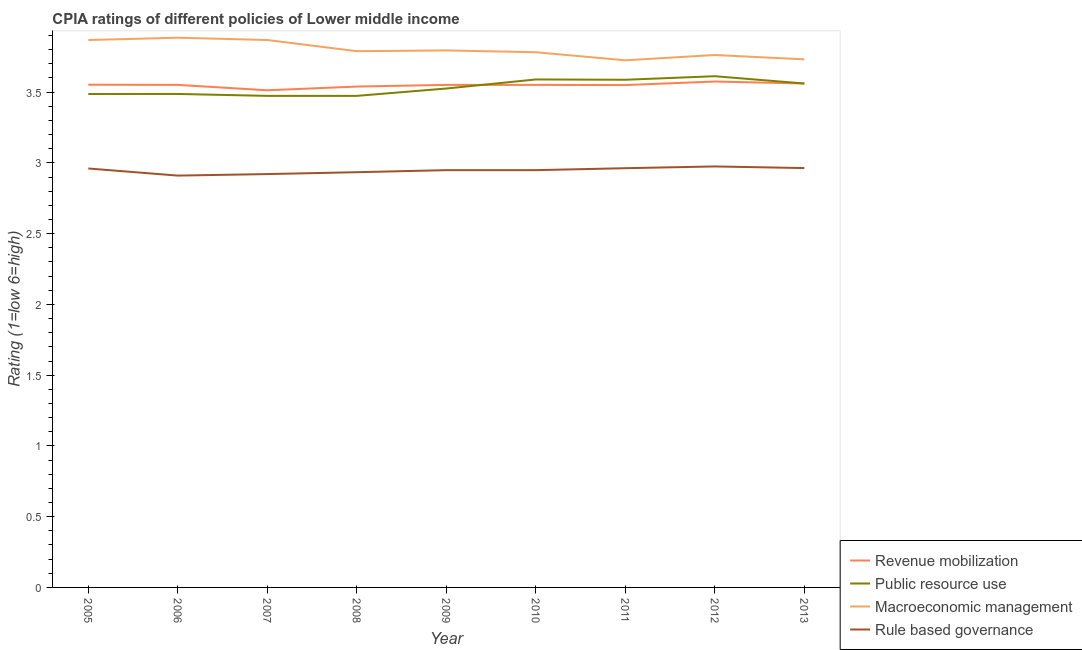Does the line corresponding to cpia rating of rule based governance intersect with the line corresponding to cpia rating of revenue mobilization?
Your answer should be compact. No. What is the cpia rating of public resource use in 2008?
Give a very brief answer. 3.47. Across all years, what is the maximum cpia rating of revenue mobilization?
Your answer should be compact. 3.58. Across all years, what is the minimum cpia rating of macroeconomic management?
Make the answer very short. 3.73. What is the total cpia rating of revenue mobilization in the graph?
Ensure brevity in your answer.  31.95. What is the difference between the cpia rating of public resource use in 2005 and that in 2008?
Give a very brief answer. 0.01. What is the difference between the cpia rating of macroeconomic management in 2012 and the cpia rating of rule based governance in 2007?
Make the answer very short. 0.84. What is the average cpia rating of revenue mobilization per year?
Offer a very short reply. 3.55. In the year 2008, what is the difference between the cpia rating of revenue mobilization and cpia rating of public resource use?
Your response must be concise. 0.07. What is the ratio of the cpia rating of rule based governance in 2009 to that in 2013?
Provide a short and direct response. 1. What is the difference between the highest and the second highest cpia rating of macroeconomic management?
Provide a succinct answer. 0.02. What is the difference between the highest and the lowest cpia rating of macroeconomic management?
Keep it short and to the point. 0.16. Is it the case that in every year, the sum of the cpia rating of macroeconomic management and cpia rating of revenue mobilization is greater than the sum of cpia rating of public resource use and cpia rating of rule based governance?
Provide a succinct answer. Yes. Is it the case that in every year, the sum of the cpia rating of revenue mobilization and cpia rating of public resource use is greater than the cpia rating of macroeconomic management?
Provide a succinct answer. Yes. Does the cpia rating of revenue mobilization monotonically increase over the years?
Keep it short and to the point. No. How many lines are there?
Your answer should be very brief. 4. What is the difference between two consecutive major ticks on the Y-axis?
Ensure brevity in your answer.  0.5. Does the graph contain any zero values?
Offer a very short reply. No. Does the graph contain grids?
Your answer should be compact. No. Where does the legend appear in the graph?
Provide a short and direct response. Bottom right. How are the legend labels stacked?
Your answer should be very brief. Vertical. What is the title of the graph?
Provide a short and direct response. CPIA ratings of different policies of Lower middle income. Does "CO2 damage" appear as one of the legend labels in the graph?
Offer a terse response. No. What is the label or title of the X-axis?
Offer a very short reply. Year. What is the label or title of the Y-axis?
Provide a succinct answer. Rating (1=low 6=high). What is the Rating (1=low 6=high) in Revenue mobilization in 2005?
Your response must be concise. 3.55. What is the Rating (1=low 6=high) of Public resource use in 2005?
Your response must be concise. 3.49. What is the Rating (1=low 6=high) in Macroeconomic management in 2005?
Provide a succinct answer. 3.87. What is the Rating (1=low 6=high) of Rule based governance in 2005?
Provide a short and direct response. 2.96. What is the Rating (1=low 6=high) in Revenue mobilization in 2006?
Provide a short and direct response. 3.55. What is the Rating (1=low 6=high) of Public resource use in 2006?
Provide a short and direct response. 3.49. What is the Rating (1=low 6=high) of Macroeconomic management in 2006?
Your answer should be compact. 3.88. What is the Rating (1=low 6=high) in Rule based governance in 2006?
Ensure brevity in your answer.  2.91. What is the Rating (1=low 6=high) of Revenue mobilization in 2007?
Provide a succinct answer. 3.51. What is the Rating (1=low 6=high) of Public resource use in 2007?
Offer a very short reply. 3.47. What is the Rating (1=low 6=high) of Macroeconomic management in 2007?
Your response must be concise. 3.87. What is the Rating (1=low 6=high) of Rule based governance in 2007?
Your response must be concise. 2.92. What is the Rating (1=low 6=high) of Revenue mobilization in 2008?
Ensure brevity in your answer.  3.54. What is the Rating (1=low 6=high) of Public resource use in 2008?
Ensure brevity in your answer.  3.47. What is the Rating (1=low 6=high) of Macroeconomic management in 2008?
Give a very brief answer. 3.79. What is the Rating (1=low 6=high) of Rule based governance in 2008?
Offer a very short reply. 2.93. What is the Rating (1=low 6=high) in Revenue mobilization in 2009?
Your answer should be compact. 3.55. What is the Rating (1=low 6=high) in Public resource use in 2009?
Make the answer very short. 3.53. What is the Rating (1=low 6=high) in Macroeconomic management in 2009?
Ensure brevity in your answer.  3.79. What is the Rating (1=low 6=high) of Rule based governance in 2009?
Offer a terse response. 2.95. What is the Rating (1=low 6=high) in Revenue mobilization in 2010?
Provide a succinct answer. 3.55. What is the Rating (1=low 6=high) of Public resource use in 2010?
Your answer should be compact. 3.59. What is the Rating (1=low 6=high) of Macroeconomic management in 2010?
Ensure brevity in your answer.  3.78. What is the Rating (1=low 6=high) in Rule based governance in 2010?
Your response must be concise. 2.95. What is the Rating (1=low 6=high) of Revenue mobilization in 2011?
Make the answer very short. 3.55. What is the Rating (1=low 6=high) of Public resource use in 2011?
Provide a short and direct response. 3.59. What is the Rating (1=low 6=high) in Macroeconomic management in 2011?
Provide a succinct answer. 3.73. What is the Rating (1=low 6=high) of Rule based governance in 2011?
Ensure brevity in your answer.  2.96. What is the Rating (1=low 6=high) of Revenue mobilization in 2012?
Ensure brevity in your answer.  3.58. What is the Rating (1=low 6=high) in Public resource use in 2012?
Offer a terse response. 3.61. What is the Rating (1=low 6=high) in Macroeconomic management in 2012?
Give a very brief answer. 3.76. What is the Rating (1=low 6=high) of Rule based governance in 2012?
Give a very brief answer. 2.98. What is the Rating (1=low 6=high) in Revenue mobilization in 2013?
Make the answer very short. 3.56. What is the Rating (1=low 6=high) in Public resource use in 2013?
Your answer should be very brief. 3.56. What is the Rating (1=low 6=high) of Macroeconomic management in 2013?
Your answer should be compact. 3.73. What is the Rating (1=low 6=high) in Rule based governance in 2013?
Your answer should be compact. 2.96. Across all years, what is the maximum Rating (1=low 6=high) in Revenue mobilization?
Offer a very short reply. 3.58. Across all years, what is the maximum Rating (1=low 6=high) of Public resource use?
Ensure brevity in your answer.  3.61. Across all years, what is the maximum Rating (1=low 6=high) in Macroeconomic management?
Ensure brevity in your answer.  3.88. Across all years, what is the maximum Rating (1=low 6=high) in Rule based governance?
Your answer should be very brief. 2.98. Across all years, what is the minimum Rating (1=low 6=high) of Revenue mobilization?
Keep it short and to the point. 3.51. Across all years, what is the minimum Rating (1=low 6=high) of Public resource use?
Give a very brief answer. 3.47. Across all years, what is the minimum Rating (1=low 6=high) of Macroeconomic management?
Ensure brevity in your answer.  3.73. Across all years, what is the minimum Rating (1=low 6=high) of Rule based governance?
Make the answer very short. 2.91. What is the total Rating (1=low 6=high) in Revenue mobilization in the graph?
Offer a terse response. 31.95. What is the total Rating (1=low 6=high) in Public resource use in the graph?
Your answer should be compact. 31.8. What is the total Rating (1=low 6=high) of Macroeconomic management in the graph?
Offer a terse response. 34.21. What is the total Rating (1=low 6=high) in Rule based governance in the graph?
Provide a short and direct response. 26.52. What is the difference between the Rating (1=low 6=high) in Revenue mobilization in 2005 and that in 2006?
Offer a terse response. 0. What is the difference between the Rating (1=low 6=high) in Public resource use in 2005 and that in 2006?
Keep it short and to the point. -0. What is the difference between the Rating (1=low 6=high) of Macroeconomic management in 2005 and that in 2006?
Provide a succinct answer. -0.02. What is the difference between the Rating (1=low 6=high) of Rule based governance in 2005 and that in 2006?
Give a very brief answer. 0.05. What is the difference between the Rating (1=low 6=high) in Revenue mobilization in 2005 and that in 2007?
Your response must be concise. 0.04. What is the difference between the Rating (1=low 6=high) of Public resource use in 2005 and that in 2007?
Your answer should be very brief. 0.01. What is the difference between the Rating (1=low 6=high) of Rule based governance in 2005 and that in 2007?
Your answer should be compact. 0.04. What is the difference between the Rating (1=low 6=high) of Revenue mobilization in 2005 and that in 2008?
Your answer should be very brief. 0.01. What is the difference between the Rating (1=low 6=high) in Public resource use in 2005 and that in 2008?
Ensure brevity in your answer.  0.01. What is the difference between the Rating (1=low 6=high) in Macroeconomic management in 2005 and that in 2008?
Provide a short and direct response. 0.08. What is the difference between the Rating (1=low 6=high) in Rule based governance in 2005 and that in 2008?
Provide a succinct answer. 0.03. What is the difference between the Rating (1=low 6=high) of Revenue mobilization in 2005 and that in 2009?
Keep it short and to the point. 0. What is the difference between the Rating (1=low 6=high) in Public resource use in 2005 and that in 2009?
Your answer should be compact. -0.04. What is the difference between the Rating (1=low 6=high) in Macroeconomic management in 2005 and that in 2009?
Ensure brevity in your answer.  0.07. What is the difference between the Rating (1=low 6=high) of Rule based governance in 2005 and that in 2009?
Provide a short and direct response. 0.01. What is the difference between the Rating (1=low 6=high) in Revenue mobilization in 2005 and that in 2010?
Your answer should be compact. 0. What is the difference between the Rating (1=low 6=high) in Public resource use in 2005 and that in 2010?
Provide a short and direct response. -0.1. What is the difference between the Rating (1=low 6=high) of Macroeconomic management in 2005 and that in 2010?
Ensure brevity in your answer.  0.09. What is the difference between the Rating (1=low 6=high) of Rule based governance in 2005 and that in 2010?
Provide a short and direct response. 0.01. What is the difference between the Rating (1=low 6=high) in Revenue mobilization in 2005 and that in 2011?
Make the answer very short. 0. What is the difference between the Rating (1=low 6=high) of Public resource use in 2005 and that in 2011?
Keep it short and to the point. -0.1. What is the difference between the Rating (1=low 6=high) in Macroeconomic management in 2005 and that in 2011?
Ensure brevity in your answer.  0.14. What is the difference between the Rating (1=low 6=high) in Rule based governance in 2005 and that in 2011?
Give a very brief answer. -0. What is the difference between the Rating (1=low 6=high) in Revenue mobilization in 2005 and that in 2012?
Your answer should be very brief. -0.02. What is the difference between the Rating (1=low 6=high) in Public resource use in 2005 and that in 2012?
Make the answer very short. -0.13. What is the difference between the Rating (1=low 6=high) in Macroeconomic management in 2005 and that in 2012?
Provide a succinct answer. 0.11. What is the difference between the Rating (1=low 6=high) of Rule based governance in 2005 and that in 2012?
Provide a short and direct response. -0.01. What is the difference between the Rating (1=low 6=high) of Revenue mobilization in 2005 and that in 2013?
Your response must be concise. -0.01. What is the difference between the Rating (1=low 6=high) in Public resource use in 2005 and that in 2013?
Provide a succinct answer. -0.07. What is the difference between the Rating (1=low 6=high) in Macroeconomic management in 2005 and that in 2013?
Your answer should be very brief. 0.14. What is the difference between the Rating (1=low 6=high) of Rule based governance in 2005 and that in 2013?
Your response must be concise. -0. What is the difference between the Rating (1=low 6=high) of Revenue mobilization in 2006 and that in 2007?
Your answer should be very brief. 0.04. What is the difference between the Rating (1=low 6=high) of Public resource use in 2006 and that in 2007?
Your answer should be compact. 0.01. What is the difference between the Rating (1=low 6=high) of Macroeconomic management in 2006 and that in 2007?
Keep it short and to the point. 0.02. What is the difference between the Rating (1=low 6=high) of Rule based governance in 2006 and that in 2007?
Offer a very short reply. -0.01. What is the difference between the Rating (1=low 6=high) in Revenue mobilization in 2006 and that in 2008?
Your response must be concise. 0.01. What is the difference between the Rating (1=low 6=high) of Public resource use in 2006 and that in 2008?
Your response must be concise. 0.01. What is the difference between the Rating (1=low 6=high) of Macroeconomic management in 2006 and that in 2008?
Give a very brief answer. 0.1. What is the difference between the Rating (1=low 6=high) of Rule based governance in 2006 and that in 2008?
Ensure brevity in your answer.  -0.02. What is the difference between the Rating (1=low 6=high) in Revenue mobilization in 2006 and that in 2009?
Make the answer very short. 0. What is the difference between the Rating (1=low 6=high) of Public resource use in 2006 and that in 2009?
Keep it short and to the point. -0.04. What is the difference between the Rating (1=low 6=high) in Macroeconomic management in 2006 and that in 2009?
Offer a very short reply. 0.09. What is the difference between the Rating (1=low 6=high) of Rule based governance in 2006 and that in 2009?
Offer a terse response. -0.04. What is the difference between the Rating (1=low 6=high) in Public resource use in 2006 and that in 2010?
Ensure brevity in your answer.  -0.1. What is the difference between the Rating (1=low 6=high) in Macroeconomic management in 2006 and that in 2010?
Provide a short and direct response. 0.1. What is the difference between the Rating (1=low 6=high) of Rule based governance in 2006 and that in 2010?
Give a very brief answer. -0.04. What is the difference between the Rating (1=low 6=high) of Revenue mobilization in 2006 and that in 2011?
Make the answer very short. 0. What is the difference between the Rating (1=low 6=high) of Public resource use in 2006 and that in 2011?
Offer a terse response. -0.1. What is the difference between the Rating (1=low 6=high) in Macroeconomic management in 2006 and that in 2011?
Offer a very short reply. 0.16. What is the difference between the Rating (1=low 6=high) of Rule based governance in 2006 and that in 2011?
Keep it short and to the point. -0.05. What is the difference between the Rating (1=low 6=high) of Revenue mobilization in 2006 and that in 2012?
Offer a terse response. -0.02. What is the difference between the Rating (1=low 6=high) in Public resource use in 2006 and that in 2012?
Give a very brief answer. -0.13. What is the difference between the Rating (1=low 6=high) in Macroeconomic management in 2006 and that in 2012?
Your answer should be very brief. 0.12. What is the difference between the Rating (1=low 6=high) of Rule based governance in 2006 and that in 2012?
Your answer should be compact. -0.06. What is the difference between the Rating (1=low 6=high) in Revenue mobilization in 2006 and that in 2013?
Make the answer very short. -0.01. What is the difference between the Rating (1=low 6=high) of Public resource use in 2006 and that in 2013?
Provide a short and direct response. -0.07. What is the difference between the Rating (1=low 6=high) of Macroeconomic management in 2006 and that in 2013?
Your answer should be compact. 0.15. What is the difference between the Rating (1=low 6=high) in Rule based governance in 2006 and that in 2013?
Give a very brief answer. -0.05. What is the difference between the Rating (1=low 6=high) in Revenue mobilization in 2007 and that in 2008?
Offer a very short reply. -0.03. What is the difference between the Rating (1=low 6=high) of Public resource use in 2007 and that in 2008?
Offer a very short reply. 0. What is the difference between the Rating (1=low 6=high) of Macroeconomic management in 2007 and that in 2008?
Give a very brief answer. 0.08. What is the difference between the Rating (1=low 6=high) of Rule based governance in 2007 and that in 2008?
Keep it short and to the point. -0.01. What is the difference between the Rating (1=low 6=high) in Revenue mobilization in 2007 and that in 2009?
Offer a very short reply. -0.04. What is the difference between the Rating (1=low 6=high) in Public resource use in 2007 and that in 2009?
Give a very brief answer. -0.05. What is the difference between the Rating (1=low 6=high) of Macroeconomic management in 2007 and that in 2009?
Provide a short and direct response. 0.07. What is the difference between the Rating (1=low 6=high) in Rule based governance in 2007 and that in 2009?
Your response must be concise. -0.03. What is the difference between the Rating (1=low 6=high) in Revenue mobilization in 2007 and that in 2010?
Your answer should be very brief. -0.04. What is the difference between the Rating (1=low 6=high) of Public resource use in 2007 and that in 2010?
Provide a succinct answer. -0.12. What is the difference between the Rating (1=low 6=high) of Macroeconomic management in 2007 and that in 2010?
Your answer should be compact. 0.09. What is the difference between the Rating (1=low 6=high) in Rule based governance in 2007 and that in 2010?
Your answer should be very brief. -0.03. What is the difference between the Rating (1=low 6=high) in Revenue mobilization in 2007 and that in 2011?
Offer a very short reply. -0.04. What is the difference between the Rating (1=low 6=high) in Public resource use in 2007 and that in 2011?
Your answer should be compact. -0.11. What is the difference between the Rating (1=low 6=high) of Macroeconomic management in 2007 and that in 2011?
Offer a very short reply. 0.14. What is the difference between the Rating (1=low 6=high) of Rule based governance in 2007 and that in 2011?
Give a very brief answer. -0.04. What is the difference between the Rating (1=low 6=high) in Revenue mobilization in 2007 and that in 2012?
Your answer should be very brief. -0.06. What is the difference between the Rating (1=low 6=high) in Public resource use in 2007 and that in 2012?
Provide a short and direct response. -0.14. What is the difference between the Rating (1=low 6=high) in Macroeconomic management in 2007 and that in 2012?
Provide a short and direct response. 0.11. What is the difference between the Rating (1=low 6=high) in Rule based governance in 2007 and that in 2012?
Your answer should be very brief. -0.05. What is the difference between the Rating (1=low 6=high) in Revenue mobilization in 2007 and that in 2013?
Your response must be concise. -0.05. What is the difference between the Rating (1=low 6=high) of Public resource use in 2007 and that in 2013?
Ensure brevity in your answer.  -0.09. What is the difference between the Rating (1=low 6=high) in Macroeconomic management in 2007 and that in 2013?
Provide a short and direct response. 0.14. What is the difference between the Rating (1=low 6=high) in Rule based governance in 2007 and that in 2013?
Ensure brevity in your answer.  -0.04. What is the difference between the Rating (1=low 6=high) in Revenue mobilization in 2008 and that in 2009?
Your answer should be compact. -0.01. What is the difference between the Rating (1=low 6=high) of Public resource use in 2008 and that in 2009?
Give a very brief answer. -0.05. What is the difference between the Rating (1=low 6=high) of Macroeconomic management in 2008 and that in 2009?
Provide a short and direct response. -0.01. What is the difference between the Rating (1=low 6=high) in Rule based governance in 2008 and that in 2009?
Keep it short and to the point. -0.01. What is the difference between the Rating (1=low 6=high) of Revenue mobilization in 2008 and that in 2010?
Your response must be concise. -0.01. What is the difference between the Rating (1=low 6=high) of Public resource use in 2008 and that in 2010?
Your answer should be very brief. -0.12. What is the difference between the Rating (1=low 6=high) in Macroeconomic management in 2008 and that in 2010?
Your answer should be compact. 0.01. What is the difference between the Rating (1=low 6=high) in Rule based governance in 2008 and that in 2010?
Offer a very short reply. -0.01. What is the difference between the Rating (1=low 6=high) in Revenue mobilization in 2008 and that in 2011?
Make the answer very short. -0.01. What is the difference between the Rating (1=low 6=high) of Public resource use in 2008 and that in 2011?
Offer a terse response. -0.11. What is the difference between the Rating (1=low 6=high) of Macroeconomic management in 2008 and that in 2011?
Offer a terse response. 0.06. What is the difference between the Rating (1=low 6=high) of Rule based governance in 2008 and that in 2011?
Provide a short and direct response. -0.03. What is the difference between the Rating (1=low 6=high) of Revenue mobilization in 2008 and that in 2012?
Your response must be concise. -0.04. What is the difference between the Rating (1=low 6=high) of Public resource use in 2008 and that in 2012?
Provide a succinct answer. -0.14. What is the difference between the Rating (1=low 6=high) of Macroeconomic management in 2008 and that in 2012?
Your answer should be very brief. 0.03. What is the difference between the Rating (1=low 6=high) of Rule based governance in 2008 and that in 2012?
Your answer should be very brief. -0.04. What is the difference between the Rating (1=low 6=high) of Revenue mobilization in 2008 and that in 2013?
Provide a succinct answer. -0.02. What is the difference between the Rating (1=low 6=high) of Public resource use in 2008 and that in 2013?
Make the answer very short. -0.09. What is the difference between the Rating (1=low 6=high) in Macroeconomic management in 2008 and that in 2013?
Ensure brevity in your answer.  0.06. What is the difference between the Rating (1=low 6=high) of Rule based governance in 2008 and that in 2013?
Ensure brevity in your answer.  -0.03. What is the difference between the Rating (1=low 6=high) of Revenue mobilization in 2009 and that in 2010?
Offer a terse response. 0. What is the difference between the Rating (1=low 6=high) of Public resource use in 2009 and that in 2010?
Your response must be concise. -0.06. What is the difference between the Rating (1=low 6=high) of Macroeconomic management in 2009 and that in 2010?
Your response must be concise. 0.01. What is the difference between the Rating (1=low 6=high) of Revenue mobilization in 2009 and that in 2011?
Provide a short and direct response. 0. What is the difference between the Rating (1=low 6=high) of Public resource use in 2009 and that in 2011?
Provide a succinct answer. -0.06. What is the difference between the Rating (1=low 6=high) of Macroeconomic management in 2009 and that in 2011?
Offer a very short reply. 0.07. What is the difference between the Rating (1=low 6=high) of Rule based governance in 2009 and that in 2011?
Provide a succinct answer. -0.01. What is the difference between the Rating (1=low 6=high) in Revenue mobilization in 2009 and that in 2012?
Your answer should be compact. -0.02. What is the difference between the Rating (1=low 6=high) of Public resource use in 2009 and that in 2012?
Give a very brief answer. -0.09. What is the difference between the Rating (1=low 6=high) of Macroeconomic management in 2009 and that in 2012?
Offer a very short reply. 0.03. What is the difference between the Rating (1=low 6=high) of Rule based governance in 2009 and that in 2012?
Your answer should be very brief. -0.03. What is the difference between the Rating (1=low 6=high) in Revenue mobilization in 2009 and that in 2013?
Offer a very short reply. -0.01. What is the difference between the Rating (1=low 6=high) of Public resource use in 2009 and that in 2013?
Your answer should be compact. -0.04. What is the difference between the Rating (1=low 6=high) in Macroeconomic management in 2009 and that in 2013?
Provide a succinct answer. 0.06. What is the difference between the Rating (1=low 6=high) of Rule based governance in 2009 and that in 2013?
Give a very brief answer. -0.01. What is the difference between the Rating (1=low 6=high) in Revenue mobilization in 2010 and that in 2011?
Your response must be concise. 0. What is the difference between the Rating (1=low 6=high) of Public resource use in 2010 and that in 2011?
Ensure brevity in your answer.  0. What is the difference between the Rating (1=low 6=high) in Macroeconomic management in 2010 and that in 2011?
Give a very brief answer. 0.06. What is the difference between the Rating (1=low 6=high) of Rule based governance in 2010 and that in 2011?
Offer a terse response. -0.01. What is the difference between the Rating (1=low 6=high) in Revenue mobilization in 2010 and that in 2012?
Offer a very short reply. -0.02. What is the difference between the Rating (1=low 6=high) in Public resource use in 2010 and that in 2012?
Your answer should be very brief. -0.02. What is the difference between the Rating (1=low 6=high) in Macroeconomic management in 2010 and that in 2012?
Your answer should be very brief. 0.02. What is the difference between the Rating (1=low 6=high) of Rule based governance in 2010 and that in 2012?
Keep it short and to the point. -0.03. What is the difference between the Rating (1=low 6=high) in Revenue mobilization in 2010 and that in 2013?
Make the answer very short. -0.01. What is the difference between the Rating (1=low 6=high) of Public resource use in 2010 and that in 2013?
Offer a terse response. 0.03. What is the difference between the Rating (1=low 6=high) of Macroeconomic management in 2010 and that in 2013?
Keep it short and to the point. 0.05. What is the difference between the Rating (1=low 6=high) of Rule based governance in 2010 and that in 2013?
Offer a very short reply. -0.01. What is the difference between the Rating (1=low 6=high) of Revenue mobilization in 2011 and that in 2012?
Provide a succinct answer. -0.03. What is the difference between the Rating (1=low 6=high) of Public resource use in 2011 and that in 2012?
Make the answer very short. -0.03. What is the difference between the Rating (1=low 6=high) of Macroeconomic management in 2011 and that in 2012?
Give a very brief answer. -0.04. What is the difference between the Rating (1=low 6=high) of Rule based governance in 2011 and that in 2012?
Keep it short and to the point. -0.01. What is the difference between the Rating (1=low 6=high) in Revenue mobilization in 2011 and that in 2013?
Keep it short and to the point. -0.01. What is the difference between the Rating (1=low 6=high) of Public resource use in 2011 and that in 2013?
Your answer should be compact. 0.03. What is the difference between the Rating (1=low 6=high) in Macroeconomic management in 2011 and that in 2013?
Offer a terse response. -0.01. What is the difference between the Rating (1=low 6=high) of Rule based governance in 2011 and that in 2013?
Provide a short and direct response. -0. What is the difference between the Rating (1=low 6=high) in Revenue mobilization in 2012 and that in 2013?
Make the answer very short. 0.01. What is the difference between the Rating (1=low 6=high) in Public resource use in 2012 and that in 2013?
Ensure brevity in your answer.  0.05. What is the difference between the Rating (1=low 6=high) in Macroeconomic management in 2012 and that in 2013?
Ensure brevity in your answer.  0.03. What is the difference between the Rating (1=low 6=high) of Rule based governance in 2012 and that in 2013?
Offer a terse response. 0.01. What is the difference between the Rating (1=low 6=high) in Revenue mobilization in 2005 and the Rating (1=low 6=high) in Public resource use in 2006?
Provide a short and direct response. 0.07. What is the difference between the Rating (1=low 6=high) in Revenue mobilization in 2005 and the Rating (1=low 6=high) in Macroeconomic management in 2006?
Make the answer very short. -0.33. What is the difference between the Rating (1=low 6=high) of Revenue mobilization in 2005 and the Rating (1=low 6=high) of Rule based governance in 2006?
Your response must be concise. 0.64. What is the difference between the Rating (1=low 6=high) of Public resource use in 2005 and the Rating (1=low 6=high) of Macroeconomic management in 2006?
Give a very brief answer. -0.4. What is the difference between the Rating (1=low 6=high) in Public resource use in 2005 and the Rating (1=low 6=high) in Rule based governance in 2006?
Provide a short and direct response. 0.58. What is the difference between the Rating (1=low 6=high) of Macroeconomic management in 2005 and the Rating (1=low 6=high) of Rule based governance in 2006?
Give a very brief answer. 0.96. What is the difference between the Rating (1=low 6=high) of Revenue mobilization in 2005 and the Rating (1=low 6=high) of Public resource use in 2007?
Make the answer very short. 0.08. What is the difference between the Rating (1=low 6=high) in Revenue mobilization in 2005 and the Rating (1=low 6=high) in Macroeconomic management in 2007?
Make the answer very short. -0.32. What is the difference between the Rating (1=low 6=high) of Revenue mobilization in 2005 and the Rating (1=low 6=high) of Rule based governance in 2007?
Give a very brief answer. 0.63. What is the difference between the Rating (1=low 6=high) in Public resource use in 2005 and the Rating (1=low 6=high) in Macroeconomic management in 2007?
Provide a succinct answer. -0.38. What is the difference between the Rating (1=low 6=high) in Public resource use in 2005 and the Rating (1=low 6=high) in Rule based governance in 2007?
Make the answer very short. 0.57. What is the difference between the Rating (1=low 6=high) in Macroeconomic management in 2005 and the Rating (1=low 6=high) in Rule based governance in 2007?
Offer a very short reply. 0.95. What is the difference between the Rating (1=low 6=high) in Revenue mobilization in 2005 and the Rating (1=low 6=high) in Public resource use in 2008?
Offer a very short reply. 0.08. What is the difference between the Rating (1=low 6=high) in Revenue mobilization in 2005 and the Rating (1=low 6=high) in Macroeconomic management in 2008?
Provide a short and direct response. -0.24. What is the difference between the Rating (1=low 6=high) of Revenue mobilization in 2005 and the Rating (1=low 6=high) of Rule based governance in 2008?
Your answer should be compact. 0.62. What is the difference between the Rating (1=low 6=high) of Public resource use in 2005 and the Rating (1=low 6=high) of Macroeconomic management in 2008?
Your response must be concise. -0.3. What is the difference between the Rating (1=low 6=high) of Public resource use in 2005 and the Rating (1=low 6=high) of Rule based governance in 2008?
Provide a short and direct response. 0.55. What is the difference between the Rating (1=low 6=high) in Macroeconomic management in 2005 and the Rating (1=low 6=high) in Rule based governance in 2008?
Your answer should be compact. 0.93. What is the difference between the Rating (1=low 6=high) of Revenue mobilization in 2005 and the Rating (1=low 6=high) of Public resource use in 2009?
Ensure brevity in your answer.  0.03. What is the difference between the Rating (1=low 6=high) of Revenue mobilization in 2005 and the Rating (1=low 6=high) of Macroeconomic management in 2009?
Offer a very short reply. -0.24. What is the difference between the Rating (1=low 6=high) of Revenue mobilization in 2005 and the Rating (1=low 6=high) of Rule based governance in 2009?
Ensure brevity in your answer.  0.6. What is the difference between the Rating (1=low 6=high) of Public resource use in 2005 and the Rating (1=low 6=high) of Macroeconomic management in 2009?
Your answer should be very brief. -0.31. What is the difference between the Rating (1=low 6=high) of Public resource use in 2005 and the Rating (1=low 6=high) of Rule based governance in 2009?
Make the answer very short. 0.54. What is the difference between the Rating (1=low 6=high) of Macroeconomic management in 2005 and the Rating (1=low 6=high) of Rule based governance in 2009?
Your response must be concise. 0.92. What is the difference between the Rating (1=low 6=high) of Revenue mobilization in 2005 and the Rating (1=low 6=high) of Public resource use in 2010?
Provide a succinct answer. -0.04. What is the difference between the Rating (1=low 6=high) in Revenue mobilization in 2005 and the Rating (1=low 6=high) in Macroeconomic management in 2010?
Ensure brevity in your answer.  -0.23. What is the difference between the Rating (1=low 6=high) of Revenue mobilization in 2005 and the Rating (1=low 6=high) of Rule based governance in 2010?
Give a very brief answer. 0.6. What is the difference between the Rating (1=low 6=high) in Public resource use in 2005 and the Rating (1=low 6=high) in Macroeconomic management in 2010?
Keep it short and to the point. -0.3. What is the difference between the Rating (1=low 6=high) in Public resource use in 2005 and the Rating (1=low 6=high) in Rule based governance in 2010?
Make the answer very short. 0.54. What is the difference between the Rating (1=low 6=high) of Macroeconomic management in 2005 and the Rating (1=low 6=high) of Rule based governance in 2010?
Keep it short and to the point. 0.92. What is the difference between the Rating (1=low 6=high) in Revenue mobilization in 2005 and the Rating (1=low 6=high) in Public resource use in 2011?
Offer a very short reply. -0.03. What is the difference between the Rating (1=low 6=high) in Revenue mobilization in 2005 and the Rating (1=low 6=high) in Macroeconomic management in 2011?
Your answer should be very brief. -0.17. What is the difference between the Rating (1=low 6=high) of Revenue mobilization in 2005 and the Rating (1=low 6=high) of Rule based governance in 2011?
Your response must be concise. 0.59. What is the difference between the Rating (1=low 6=high) of Public resource use in 2005 and the Rating (1=low 6=high) of Macroeconomic management in 2011?
Offer a very short reply. -0.24. What is the difference between the Rating (1=low 6=high) of Public resource use in 2005 and the Rating (1=low 6=high) of Rule based governance in 2011?
Give a very brief answer. 0.52. What is the difference between the Rating (1=low 6=high) of Macroeconomic management in 2005 and the Rating (1=low 6=high) of Rule based governance in 2011?
Your response must be concise. 0.91. What is the difference between the Rating (1=low 6=high) of Revenue mobilization in 2005 and the Rating (1=low 6=high) of Public resource use in 2012?
Your answer should be compact. -0.06. What is the difference between the Rating (1=low 6=high) in Revenue mobilization in 2005 and the Rating (1=low 6=high) in Macroeconomic management in 2012?
Your answer should be compact. -0.21. What is the difference between the Rating (1=low 6=high) in Revenue mobilization in 2005 and the Rating (1=low 6=high) in Rule based governance in 2012?
Provide a succinct answer. 0.58. What is the difference between the Rating (1=low 6=high) of Public resource use in 2005 and the Rating (1=low 6=high) of Macroeconomic management in 2012?
Offer a very short reply. -0.28. What is the difference between the Rating (1=low 6=high) of Public resource use in 2005 and the Rating (1=low 6=high) of Rule based governance in 2012?
Offer a very short reply. 0.51. What is the difference between the Rating (1=low 6=high) in Macroeconomic management in 2005 and the Rating (1=low 6=high) in Rule based governance in 2012?
Offer a terse response. 0.89. What is the difference between the Rating (1=low 6=high) in Revenue mobilization in 2005 and the Rating (1=low 6=high) in Public resource use in 2013?
Ensure brevity in your answer.  -0.01. What is the difference between the Rating (1=low 6=high) in Revenue mobilization in 2005 and the Rating (1=low 6=high) in Macroeconomic management in 2013?
Give a very brief answer. -0.18. What is the difference between the Rating (1=low 6=high) of Revenue mobilization in 2005 and the Rating (1=low 6=high) of Rule based governance in 2013?
Keep it short and to the point. 0.59. What is the difference between the Rating (1=low 6=high) in Public resource use in 2005 and the Rating (1=low 6=high) in Macroeconomic management in 2013?
Offer a very short reply. -0.24. What is the difference between the Rating (1=low 6=high) of Public resource use in 2005 and the Rating (1=low 6=high) of Rule based governance in 2013?
Provide a short and direct response. 0.52. What is the difference between the Rating (1=low 6=high) of Macroeconomic management in 2005 and the Rating (1=low 6=high) of Rule based governance in 2013?
Provide a short and direct response. 0.91. What is the difference between the Rating (1=low 6=high) in Revenue mobilization in 2006 and the Rating (1=low 6=high) in Public resource use in 2007?
Offer a terse response. 0.08. What is the difference between the Rating (1=low 6=high) of Revenue mobilization in 2006 and the Rating (1=low 6=high) of Macroeconomic management in 2007?
Provide a succinct answer. -0.32. What is the difference between the Rating (1=low 6=high) in Revenue mobilization in 2006 and the Rating (1=low 6=high) in Rule based governance in 2007?
Provide a succinct answer. 0.63. What is the difference between the Rating (1=low 6=high) in Public resource use in 2006 and the Rating (1=low 6=high) in Macroeconomic management in 2007?
Your answer should be compact. -0.38. What is the difference between the Rating (1=low 6=high) of Public resource use in 2006 and the Rating (1=low 6=high) of Rule based governance in 2007?
Your answer should be compact. 0.57. What is the difference between the Rating (1=low 6=high) in Macroeconomic management in 2006 and the Rating (1=low 6=high) in Rule based governance in 2007?
Offer a terse response. 0.96. What is the difference between the Rating (1=low 6=high) in Revenue mobilization in 2006 and the Rating (1=low 6=high) in Public resource use in 2008?
Your response must be concise. 0.08. What is the difference between the Rating (1=low 6=high) of Revenue mobilization in 2006 and the Rating (1=low 6=high) of Macroeconomic management in 2008?
Offer a terse response. -0.24. What is the difference between the Rating (1=low 6=high) in Revenue mobilization in 2006 and the Rating (1=low 6=high) in Rule based governance in 2008?
Your answer should be very brief. 0.62. What is the difference between the Rating (1=low 6=high) of Public resource use in 2006 and the Rating (1=low 6=high) of Macroeconomic management in 2008?
Your response must be concise. -0.3. What is the difference between the Rating (1=low 6=high) of Public resource use in 2006 and the Rating (1=low 6=high) of Rule based governance in 2008?
Your answer should be very brief. 0.55. What is the difference between the Rating (1=low 6=high) of Macroeconomic management in 2006 and the Rating (1=low 6=high) of Rule based governance in 2008?
Ensure brevity in your answer.  0.95. What is the difference between the Rating (1=low 6=high) of Revenue mobilization in 2006 and the Rating (1=low 6=high) of Public resource use in 2009?
Provide a succinct answer. 0.03. What is the difference between the Rating (1=low 6=high) in Revenue mobilization in 2006 and the Rating (1=low 6=high) in Macroeconomic management in 2009?
Make the answer very short. -0.24. What is the difference between the Rating (1=low 6=high) of Revenue mobilization in 2006 and the Rating (1=low 6=high) of Rule based governance in 2009?
Your answer should be compact. 0.6. What is the difference between the Rating (1=low 6=high) of Public resource use in 2006 and the Rating (1=low 6=high) of Macroeconomic management in 2009?
Give a very brief answer. -0.31. What is the difference between the Rating (1=low 6=high) of Public resource use in 2006 and the Rating (1=low 6=high) of Rule based governance in 2009?
Your response must be concise. 0.54. What is the difference between the Rating (1=low 6=high) in Macroeconomic management in 2006 and the Rating (1=low 6=high) in Rule based governance in 2009?
Ensure brevity in your answer.  0.94. What is the difference between the Rating (1=low 6=high) of Revenue mobilization in 2006 and the Rating (1=low 6=high) of Public resource use in 2010?
Keep it short and to the point. -0.04. What is the difference between the Rating (1=low 6=high) in Revenue mobilization in 2006 and the Rating (1=low 6=high) in Macroeconomic management in 2010?
Provide a short and direct response. -0.23. What is the difference between the Rating (1=low 6=high) of Revenue mobilization in 2006 and the Rating (1=low 6=high) of Rule based governance in 2010?
Your answer should be very brief. 0.6. What is the difference between the Rating (1=low 6=high) of Public resource use in 2006 and the Rating (1=low 6=high) of Macroeconomic management in 2010?
Provide a succinct answer. -0.29. What is the difference between the Rating (1=low 6=high) in Public resource use in 2006 and the Rating (1=low 6=high) in Rule based governance in 2010?
Your answer should be very brief. 0.54. What is the difference between the Rating (1=low 6=high) in Macroeconomic management in 2006 and the Rating (1=low 6=high) in Rule based governance in 2010?
Offer a terse response. 0.94. What is the difference between the Rating (1=low 6=high) in Revenue mobilization in 2006 and the Rating (1=low 6=high) in Public resource use in 2011?
Make the answer very short. -0.04. What is the difference between the Rating (1=low 6=high) in Revenue mobilization in 2006 and the Rating (1=low 6=high) in Macroeconomic management in 2011?
Your response must be concise. -0.17. What is the difference between the Rating (1=low 6=high) in Revenue mobilization in 2006 and the Rating (1=low 6=high) in Rule based governance in 2011?
Offer a terse response. 0.59. What is the difference between the Rating (1=low 6=high) of Public resource use in 2006 and the Rating (1=low 6=high) of Macroeconomic management in 2011?
Your answer should be very brief. -0.24. What is the difference between the Rating (1=low 6=high) in Public resource use in 2006 and the Rating (1=low 6=high) in Rule based governance in 2011?
Ensure brevity in your answer.  0.52. What is the difference between the Rating (1=low 6=high) in Macroeconomic management in 2006 and the Rating (1=low 6=high) in Rule based governance in 2011?
Your answer should be compact. 0.92. What is the difference between the Rating (1=low 6=high) in Revenue mobilization in 2006 and the Rating (1=low 6=high) in Public resource use in 2012?
Your response must be concise. -0.06. What is the difference between the Rating (1=low 6=high) in Revenue mobilization in 2006 and the Rating (1=low 6=high) in Macroeconomic management in 2012?
Ensure brevity in your answer.  -0.21. What is the difference between the Rating (1=low 6=high) of Revenue mobilization in 2006 and the Rating (1=low 6=high) of Rule based governance in 2012?
Your answer should be very brief. 0.58. What is the difference between the Rating (1=low 6=high) in Public resource use in 2006 and the Rating (1=low 6=high) in Macroeconomic management in 2012?
Keep it short and to the point. -0.28. What is the difference between the Rating (1=low 6=high) in Public resource use in 2006 and the Rating (1=low 6=high) in Rule based governance in 2012?
Provide a short and direct response. 0.51. What is the difference between the Rating (1=low 6=high) in Macroeconomic management in 2006 and the Rating (1=low 6=high) in Rule based governance in 2012?
Your answer should be very brief. 0.91. What is the difference between the Rating (1=low 6=high) of Revenue mobilization in 2006 and the Rating (1=low 6=high) of Public resource use in 2013?
Your response must be concise. -0.01. What is the difference between the Rating (1=low 6=high) in Revenue mobilization in 2006 and the Rating (1=low 6=high) in Macroeconomic management in 2013?
Ensure brevity in your answer.  -0.18. What is the difference between the Rating (1=low 6=high) in Revenue mobilization in 2006 and the Rating (1=low 6=high) in Rule based governance in 2013?
Give a very brief answer. 0.59. What is the difference between the Rating (1=low 6=high) in Public resource use in 2006 and the Rating (1=low 6=high) in Macroeconomic management in 2013?
Offer a very short reply. -0.24. What is the difference between the Rating (1=low 6=high) in Public resource use in 2006 and the Rating (1=low 6=high) in Rule based governance in 2013?
Your answer should be very brief. 0.52. What is the difference between the Rating (1=low 6=high) of Macroeconomic management in 2006 and the Rating (1=low 6=high) of Rule based governance in 2013?
Ensure brevity in your answer.  0.92. What is the difference between the Rating (1=low 6=high) in Revenue mobilization in 2007 and the Rating (1=low 6=high) in Public resource use in 2008?
Your answer should be very brief. 0.04. What is the difference between the Rating (1=low 6=high) of Revenue mobilization in 2007 and the Rating (1=low 6=high) of Macroeconomic management in 2008?
Make the answer very short. -0.28. What is the difference between the Rating (1=low 6=high) in Revenue mobilization in 2007 and the Rating (1=low 6=high) in Rule based governance in 2008?
Provide a succinct answer. 0.58. What is the difference between the Rating (1=low 6=high) in Public resource use in 2007 and the Rating (1=low 6=high) in Macroeconomic management in 2008?
Offer a very short reply. -0.32. What is the difference between the Rating (1=low 6=high) of Public resource use in 2007 and the Rating (1=low 6=high) of Rule based governance in 2008?
Keep it short and to the point. 0.54. What is the difference between the Rating (1=low 6=high) of Macroeconomic management in 2007 and the Rating (1=low 6=high) of Rule based governance in 2008?
Your response must be concise. 0.93. What is the difference between the Rating (1=low 6=high) in Revenue mobilization in 2007 and the Rating (1=low 6=high) in Public resource use in 2009?
Your answer should be compact. -0.01. What is the difference between the Rating (1=low 6=high) of Revenue mobilization in 2007 and the Rating (1=low 6=high) of Macroeconomic management in 2009?
Make the answer very short. -0.28. What is the difference between the Rating (1=low 6=high) of Revenue mobilization in 2007 and the Rating (1=low 6=high) of Rule based governance in 2009?
Give a very brief answer. 0.56. What is the difference between the Rating (1=low 6=high) in Public resource use in 2007 and the Rating (1=low 6=high) in Macroeconomic management in 2009?
Give a very brief answer. -0.32. What is the difference between the Rating (1=low 6=high) of Public resource use in 2007 and the Rating (1=low 6=high) of Rule based governance in 2009?
Your answer should be compact. 0.53. What is the difference between the Rating (1=low 6=high) in Macroeconomic management in 2007 and the Rating (1=low 6=high) in Rule based governance in 2009?
Your answer should be compact. 0.92. What is the difference between the Rating (1=low 6=high) of Revenue mobilization in 2007 and the Rating (1=low 6=high) of Public resource use in 2010?
Your response must be concise. -0.08. What is the difference between the Rating (1=low 6=high) in Revenue mobilization in 2007 and the Rating (1=low 6=high) in Macroeconomic management in 2010?
Ensure brevity in your answer.  -0.27. What is the difference between the Rating (1=low 6=high) of Revenue mobilization in 2007 and the Rating (1=low 6=high) of Rule based governance in 2010?
Provide a short and direct response. 0.56. What is the difference between the Rating (1=low 6=high) in Public resource use in 2007 and the Rating (1=low 6=high) in Macroeconomic management in 2010?
Give a very brief answer. -0.31. What is the difference between the Rating (1=low 6=high) of Public resource use in 2007 and the Rating (1=low 6=high) of Rule based governance in 2010?
Offer a very short reply. 0.53. What is the difference between the Rating (1=low 6=high) in Macroeconomic management in 2007 and the Rating (1=low 6=high) in Rule based governance in 2010?
Provide a succinct answer. 0.92. What is the difference between the Rating (1=low 6=high) in Revenue mobilization in 2007 and the Rating (1=low 6=high) in Public resource use in 2011?
Make the answer very short. -0.07. What is the difference between the Rating (1=low 6=high) in Revenue mobilization in 2007 and the Rating (1=low 6=high) in Macroeconomic management in 2011?
Offer a very short reply. -0.21. What is the difference between the Rating (1=low 6=high) of Revenue mobilization in 2007 and the Rating (1=low 6=high) of Rule based governance in 2011?
Make the answer very short. 0.55. What is the difference between the Rating (1=low 6=high) of Public resource use in 2007 and the Rating (1=low 6=high) of Macroeconomic management in 2011?
Your answer should be very brief. -0.25. What is the difference between the Rating (1=low 6=high) of Public resource use in 2007 and the Rating (1=low 6=high) of Rule based governance in 2011?
Your answer should be very brief. 0.51. What is the difference between the Rating (1=low 6=high) in Macroeconomic management in 2007 and the Rating (1=low 6=high) in Rule based governance in 2011?
Offer a very short reply. 0.91. What is the difference between the Rating (1=low 6=high) of Revenue mobilization in 2007 and the Rating (1=low 6=high) of Public resource use in 2012?
Your answer should be very brief. -0.1. What is the difference between the Rating (1=low 6=high) of Revenue mobilization in 2007 and the Rating (1=low 6=high) of Macroeconomic management in 2012?
Your answer should be compact. -0.25. What is the difference between the Rating (1=low 6=high) in Revenue mobilization in 2007 and the Rating (1=low 6=high) in Rule based governance in 2012?
Give a very brief answer. 0.54. What is the difference between the Rating (1=low 6=high) in Public resource use in 2007 and the Rating (1=low 6=high) in Macroeconomic management in 2012?
Your response must be concise. -0.29. What is the difference between the Rating (1=low 6=high) of Public resource use in 2007 and the Rating (1=low 6=high) of Rule based governance in 2012?
Your answer should be very brief. 0.5. What is the difference between the Rating (1=low 6=high) in Macroeconomic management in 2007 and the Rating (1=low 6=high) in Rule based governance in 2012?
Offer a terse response. 0.89. What is the difference between the Rating (1=low 6=high) in Revenue mobilization in 2007 and the Rating (1=low 6=high) in Public resource use in 2013?
Offer a very short reply. -0.05. What is the difference between the Rating (1=low 6=high) in Revenue mobilization in 2007 and the Rating (1=low 6=high) in Macroeconomic management in 2013?
Your response must be concise. -0.22. What is the difference between the Rating (1=low 6=high) in Revenue mobilization in 2007 and the Rating (1=low 6=high) in Rule based governance in 2013?
Give a very brief answer. 0.55. What is the difference between the Rating (1=low 6=high) of Public resource use in 2007 and the Rating (1=low 6=high) of Macroeconomic management in 2013?
Provide a succinct answer. -0.26. What is the difference between the Rating (1=low 6=high) in Public resource use in 2007 and the Rating (1=low 6=high) in Rule based governance in 2013?
Give a very brief answer. 0.51. What is the difference between the Rating (1=low 6=high) of Macroeconomic management in 2007 and the Rating (1=low 6=high) of Rule based governance in 2013?
Your answer should be compact. 0.91. What is the difference between the Rating (1=low 6=high) of Revenue mobilization in 2008 and the Rating (1=low 6=high) of Public resource use in 2009?
Keep it short and to the point. 0.01. What is the difference between the Rating (1=low 6=high) in Revenue mobilization in 2008 and the Rating (1=low 6=high) in Macroeconomic management in 2009?
Offer a very short reply. -0.26. What is the difference between the Rating (1=low 6=high) in Revenue mobilization in 2008 and the Rating (1=low 6=high) in Rule based governance in 2009?
Your answer should be compact. 0.59. What is the difference between the Rating (1=low 6=high) in Public resource use in 2008 and the Rating (1=low 6=high) in Macroeconomic management in 2009?
Your response must be concise. -0.32. What is the difference between the Rating (1=low 6=high) in Public resource use in 2008 and the Rating (1=low 6=high) in Rule based governance in 2009?
Offer a terse response. 0.53. What is the difference between the Rating (1=low 6=high) of Macroeconomic management in 2008 and the Rating (1=low 6=high) of Rule based governance in 2009?
Offer a terse response. 0.84. What is the difference between the Rating (1=low 6=high) of Revenue mobilization in 2008 and the Rating (1=low 6=high) of Public resource use in 2010?
Give a very brief answer. -0.05. What is the difference between the Rating (1=low 6=high) of Revenue mobilization in 2008 and the Rating (1=low 6=high) of Macroeconomic management in 2010?
Make the answer very short. -0.24. What is the difference between the Rating (1=low 6=high) of Revenue mobilization in 2008 and the Rating (1=low 6=high) of Rule based governance in 2010?
Offer a terse response. 0.59. What is the difference between the Rating (1=low 6=high) of Public resource use in 2008 and the Rating (1=low 6=high) of Macroeconomic management in 2010?
Your answer should be very brief. -0.31. What is the difference between the Rating (1=low 6=high) in Public resource use in 2008 and the Rating (1=low 6=high) in Rule based governance in 2010?
Make the answer very short. 0.53. What is the difference between the Rating (1=low 6=high) in Macroeconomic management in 2008 and the Rating (1=low 6=high) in Rule based governance in 2010?
Offer a terse response. 0.84. What is the difference between the Rating (1=low 6=high) in Revenue mobilization in 2008 and the Rating (1=low 6=high) in Public resource use in 2011?
Your answer should be very brief. -0.05. What is the difference between the Rating (1=low 6=high) in Revenue mobilization in 2008 and the Rating (1=low 6=high) in Macroeconomic management in 2011?
Your answer should be compact. -0.19. What is the difference between the Rating (1=low 6=high) of Revenue mobilization in 2008 and the Rating (1=low 6=high) of Rule based governance in 2011?
Give a very brief answer. 0.58. What is the difference between the Rating (1=low 6=high) of Public resource use in 2008 and the Rating (1=low 6=high) of Macroeconomic management in 2011?
Give a very brief answer. -0.25. What is the difference between the Rating (1=low 6=high) of Public resource use in 2008 and the Rating (1=low 6=high) of Rule based governance in 2011?
Your response must be concise. 0.51. What is the difference between the Rating (1=low 6=high) of Macroeconomic management in 2008 and the Rating (1=low 6=high) of Rule based governance in 2011?
Offer a very short reply. 0.83. What is the difference between the Rating (1=low 6=high) of Revenue mobilization in 2008 and the Rating (1=low 6=high) of Public resource use in 2012?
Your response must be concise. -0.07. What is the difference between the Rating (1=low 6=high) of Revenue mobilization in 2008 and the Rating (1=low 6=high) of Macroeconomic management in 2012?
Your answer should be very brief. -0.22. What is the difference between the Rating (1=low 6=high) in Revenue mobilization in 2008 and the Rating (1=low 6=high) in Rule based governance in 2012?
Give a very brief answer. 0.56. What is the difference between the Rating (1=low 6=high) of Public resource use in 2008 and the Rating (1=low 6=high) of Macroeconomic management in 2012?
Ensure brevity in your answer.  -0.29. What is the difference between the Rating (1=low 6=high) of Public resource use in 2008 and the Rating (1=low 6=high) of Rule based governance in 2012?
Provide a short and direct response. 0.5. What is the difference between the Rating (1=low 6=high) of Macroeconomic management in 2008 and the Rating (1=low 6=high) of Rule based governance in 2012?
Offer a terse response. 0.81. What is the difference between the Rating (1=low 6=high) in Revenue mobilization in 2008 and the Rating (1=low 6=high) in Public resource use in 2013?
Your answer should be very brief. -0.02. What is the difference between the Rating (1=low 6=high) of Revenue mobilization in 2008 and the Rating (1=low 6=high) of Macroeconomic management in 2013?
Offer a very short reply. -0.19. What is the difference between the Rating (1=low 6=high) in Revenue mobilization in 2008 and the Rating (1=low 6=high) in Rule based governance in 2013?
Your response must be concise. 0.58. What is the difference between the Rating (1=low 6=high) in Public resource use in 2008 and the Rating (1=low 6=high) in Macroeconomic management in 2013?
Make the answer very short. -0.26. What is the difference between the Rating (1=low 6=high) of Public resource use in 2008 and the Rating (1=low 6=high) of Rule based governance in 2013?
Keep it short and to the point. 0.51. What is the difference between the Rating (1=low 6=high) in Macroeconomic management in 2008 and the Rating (1=low 6=high) in Rule based governance in 2013?
Your answer should be compact. 0.83. What is the difference between the Rating (1=low 6=high) in Revenue mobilization in 2009 and the Rating (1=low 6=high) in Public resource use in 2010?
Provide a succinct answer. -0.04. What is the difference between the Rating (1=low 6=high) in Revenue mobilization in 2009 and the Rating (1=low 6=high) in Macroeconomic management in 2010?
Your answer should be compact. -0.23. What is the difference between the Rating (1=low 6=high) in Revenue mobilization in 2009 and the Rating (1=low 6=high) in Rule based governance in 2010?
Your response must be concise. 0.6. What is the difference between the Rating (1=low 6=high) of Public resource use in 2009 and the Rating (1=low 6=high) of Macroeconomic management in 2010?
Offer a terse response. -0.26. What is the difference between the Rating (1=low 6=high) of Public resource use in 2009 and the Rating (1=low 6=high) of Rule based governance in 2010?
Your answer should be compact. 0.58. What is the difference between the Rating (1=low 6=high) in Macroeconomic management in 2009 and the Rating (1=low 6=high) in Rule based governance in 2010?
Ensure brevity in your answer.  0.85. What is the difference between the Rating (1=low 6=high) in Revenue mobilization in 2009 and the Rating (1=low 6=high) in Public resource use in 2011?
Offer a very short reply. -0.04. What is the difference between the Rating (1=low 6=high) of Revenue mobilization in 2009 and the Rating (1=low 6=high) of Macroeconomic management in 2011?
Provide a short and direct response. -0.17. What is the difference between the Rating (1=low 6=high) of Revenue mobilization in 2009 and the Rating (1=low 6=high) of Rule based governance in 2011?
Make the answer very short. 0.59. What is the difference between the Rating (1=low 6=high) in Public resource use in 2009 and the Rating (1=low 6=high) in Macroeconomic management in 2011?
Make the answer very short. -0.2. What is the difference between the Rating (1=low 6=high) of Public resource use in 2009 and the Rating (1=low 6=high) of Rule based governance in 2011?
Provide a succinct answer. 0.56. What is the difference between the Rating (1=low 6=high) of Macroeconomic management in 2009 and the Rating (1=low 6=high) of Rule based governance in 2011?
Your answer should be compact. 0.83. What is the difference between the Rating (1=low 6=high) in Revenue mobilization in 2009 and the Rating (1=low 6=high) in Public resource use in 2012?
Provide a short and direct response. -0.06. What is the difference between the Rating (1=low 6=high) in Revenue mobilization in 2009 and the Rating (1=low 6=high) in Macroeconomic management in 2012?
Your answer should be very brief. -0.21. What is the difference between the Rating (1=low 6=high) in Revenue mobilization in 2009 and the Rating (1=low 6=high) in Rule based governance in 2012?
Provide a short and direct response. 0.58. What is the difference between the Rating (1=low 6=high) in Public resource use in 2009 and the Rating (1=low 6=high) in Macroeconomic management in 2012?
Your answer should be compact. -0.24. What is the difference between the Rating (1=low 6=high) of Public resource use in 2009 and the Rating (1=low 6=high) of Rule based governance in 2012?
Keep it short and to the point. 0.55. What is the difference between the Rating (1=low 6=high) of Macroeconomic management in 2009 and the Rating (1=low 6=high) of Rule based governance in 2012?
Make the answer very short. 0.82. What is the difference between the Rating (1=low 6=high) of Revenue mobilization in 2009 and the Rating (1=low 6=high) of Public resource use in 2013?
Provide a succinct answer. -0.01. What is the difference between the Rating (1=low 6=high) in Revenue mobilization in 2009 and the Rating (1=low 6=high) in Macroeconomic management in 2013?
Your answer should be compact. -0.18. What is the difference between the Rating (1=low 6=high) of Revenue mobilization in 2009 and the Rating (1=low 6=high) of Rule based governance in 2013?
Ensure brevity in your answer.  0.59. What is the difference between the Rating (1=low 6=high) in Public resource use in 2009 and the Rating (1=low 6=high) in Macroeconomic management in 2013?
Provide a succinct answer. -0.21. What is the difference between the Rating (1=low 6=high) of Public resource use in 2009 and the Rating (1=low 6=high) of Rule based governance in 2013?
Offer a very short reply. 0.56. What is the difference between the Rating (1=low 6=high) in Macroeconomic management in 2009 and the Rating (1=low 6=high) in Rule based governance in 2013?
Offer a terse response. 0.83. What is the difference between the Rating (1=low 6=high) of Revenue mobilization in 2010 and the Rating (1=low 6=high) of Public resource use in 2011?
Make the answer very short. -0.04. What is the difference between the Rating (1=low 6=high) of Revenue mobilization in 2010 and the Rating (1=low 6=high) of Macroeconomic management in 2011?
Provide a succinct answer. -0.17. What is the difference between the Rating (1=low 6=high) of Revenue mobilization in 2010 and the Rating (1=low 6=high) of Rule based governance in 2011?
Your answer should be compact. 0.59. What is the difference between the Rating (1=low 6=high) of Public resource use in 2010 and the Rating (1=low 6=high) of Macroeconomic management in 2011?
Provide a short and direct response. -0.14. What is the difference between the Rating (1=low 6=high) of Public resource use in 2010 and the Rating (1=low 6=high) of Rule based governance in 2011?
Provide a short and direct response. 0.63. What is the difference between the Rating (1=low 6=high) in Macroeconomic management in 2010 and the Rating (1=low 6=high) in Rule based governance in 2011?
Ensure brevity in your answer.  0.82. What is the difference between the Rating (1=low 6=high) of Revenue mobilization in 2010 and the Rating (1=low 6=high) of Public resource use in 2012?
Provide a short and direct response. -0.06. What is the difference between the Rating (1=low 6=high) in Revenue mobilization in 2010 and the Rating (1=low 6=high) in Macroeconomic management in 2012?
Ensure brevity in your answer.  -0.21. What is the difference between the Rating (1=low 6=high) in Revenue mobilization in 2010 and the Rating (1=low 6=high) in Rule based governance in 2012?
Offer a terse response. 0.58. What is the difference between the Rating (1=low 6=high) in Public resource use in 2010 and the Rating (1=low 6=high) in Macroeconomic management in 2012?
Offer a terse response. -0.17. What is the difference between the Rating (1=low 6=high) in Public resource use in 2010 and the Rating (1=low 6=high) in Rule based governance in 2012?
Your response must be concise. 0.61. What is the difference between the Rating (1=low 6=high) in Macroeconomic management in 2010 and the Rating (1=low 6=high) in Rule based governance in 2012?
Provide a succinct answer. 0.81. What is the difference between the Rating (1=low 6=high) of Revenue mobilization in 2010 and the Rating (1=low 6=high) of Public resource use in 2013?
Your response must be concise. -0.01. What is the difference between the Rating (1=low 6=high) of Revenue mobilization in 2010 and the Rating (1=low 6=high) of Macroeconomic management in 2013?
Your response must be concise. -0.18. What is the difference between the Rating (1=low 6=high) of Revenue mobilization in 2010 and the Rating (1=low 6=high) of Rule based governance in 2013?
Give a very brief answer. 0.59. What is the difference between the Rating (1=low 6=high) in Public resource use in 2010 and the Rating (1=low 6=high) in Macroeconomic management in 2013?
Offer a very short reply. -0.14. What is the difference between the Rating (1=low 6=high) in Public resource use in 2010 and the Rating (1=low 6=high) in Rule based governance in 2013?
Make the answer very short. 0.63. What is the difference between the Rating (1=low 6=high) in Macroeconomic management in 2010 and the Rating (1=low 6=high) in Rule based governance in 2013?
Provide a succinct answer. 0.82. What is the difference between the Rating (1=low 6=high) in Revenue mobilization in 2011 and the Rating (1=low 6=high) in Public resource use in 2012?
Make the answer very short. -0.06. What is the difference between the Rating (1=low 6=high) of Revenue mobilization in 2011 and the Rating (1=low 6=high) of Macroeconomic management in 2012?
Provide a short and direct response. -0.21. What is the difference between the Rating (1=low 6=high) in Revenue mobilization in 2011 and the Rating (1=low 6=high) in Rule based governance in 2012?
Give a very brief answer. 0.57. What is the difference between the Rating (1=low 6=high) in Public resource use in 2011 and the Rating (1=low 6=high) in Macroeconomic management in 2012?
Your response must be concise. -0.17. What is the difference between the Rating (1=low 6=high) in Public resource use in 2011 and the Rating (1=low 6=high) in Rule based governance in 2012?
Provide a short and direct response. 0.61. What is the difference between the Rating (1=low 6=high) in Revenue mobilization in 2011 and the Rating (1=low 6=high) in Public resource use in 2013?
Offer a very short reply. -0.01. What is the difference between the Rating (1=low 6=high) in Revenue mobilization in 2011 and the Rating (1=low 6=high) in Macroeconomic management in 2013?
Make the answer very short. -0.18. What is the difference between the Rating (1=low 6=high) in Revenue mobilization in 2011 and the Rating (1=low 6=high) in Rule based governance in 2013?
Keep it short and to the point. 0.59. What is the difference between the Rating (1=low 6=high) of Public resource use in 2011 and the Rating (1=low 6=high) of Macroeconomic management in 2013?
Provide a short and direct response. -0.14. What is the difference between the Rating (1=low 6=high) in Public resource use in 2011 and the Rating (1=low 6=high) in Rule based governance in 2013?
Offer a very short reply. 0.62. What is the difference between the Rating (1=low 6=high) in Macroeconomic management in 2011 and the Rating (1=low 6=high) in Rule based governance in 2013?
Offer a terse response. 0.76. What is the difference between the Rating (1=low 6=high) in Revenue mobilization in 2012 and the Rating (1=low 6=high) in Public resource use in 2013?
Your answer should be very brief. 0.01. What is the difference between the Rating (1=low 6=high) in Revenue mobilization in 2012 and the Rating (1=low 6=high) in Macroeconomic management in 2013?
Provide a succinct answer. -0.16. What is the difference between the Rating (1=low 6=high) in Revenue mobilization in 2012 and the Rating (1=low 6=high) in Rule based governance in 2013?
Your response must be concise. 0.61. What is the difference between the Rating (1=low 6=high) in Public resource use in 2012 and the Rating (1=low 6=high) in Macroeconomic management in 2013?
Ensure brevity in your answer.  -0.12. What is the difference between the Rating (1=low 6=high) in Public resource use in 2012 and the Rating (1=low 6=high) in Rule based governance in 2013?
Your response must be concise. 0.65. What is the difference between the Rating (1=low 6=high) of Macroeconomic management in 2012 and the Rating (1=low 6=high) of Rule based governance in 2013?
Offer a very short reply. 0.8. What is the average Rating (1=low 6=high) of Revenue mobilization per year?
Ensure brevity in your answer.  3.55. What is the average Rating (1=low 6=high) of Public resource use per year?
Your response must be concise. 3.53. What is the average Rating (1=low 6=high) of Macroeconomic management per year?
Your answer should be compact. 3.8. What is the average Rating (1=low 6=high) in Rule based governance per year?
Give a very brief answer. 2.95. In the year 2005, what is the difference between the Rating (1=low 6=high) in Revenue mobilization and Rating (1=low 6=high) in Public resource use?
Keep it short and to the point. 0.07. In the year 2005, what is the difference between the Rating (1=low 6=high) of Revenue mobilization and Rating (1=low 6=high) of Macroeconomic management?
Ensure brevity in your answer.  -0.32. In the year 2005, what is the difference between the Rating (1=low 6=high) in Revenue mobilization and Rating (1=low 6=high) in Rule based governance?
Offer a terse response. 0.59. In the year 2005, what is the difference between the Rating (1=low 6=high) of Public resource use and Rating (1=low 6=high) of Macroeconomic management?
Offer a terse response. -0.38. In the year 2005, what is the difference between the Rating (1=low 6=high) of Public resource use and Rating (1=low 6=high) of Rule based governance?
Your answer should be compact. 0.53. In the year 2005, what is the difference between the Rating (1=low 6=high) of Macroeconomic management and Rating (1=low 6=high) of Rule based governance?
Offer a terse response. 0.91. In the year 2006, what is the difference between the Rating (1=low 6=high) in Revenue mobilization and Rating (1=low 6=high) in Public resource use?
Your answer should be very brief. 0.06. In the year 2006, what is the difference between the Rating (1=low 6=high) in Revenue mobilization and Rating (1=low 6=high) in Rule based governance?
Provide a succinct answer. 0.64. In the year 2006, what is the difference between the Rating (1=low 6=high) in Public resource use and Rating (1=low 6=high) in Macroeconomic management?
Provide a succinct answer. -0.4. In the year 2006, what is the difference between the Rating (1=low 6=high) of Public resource use and Rating (1=low 6=high) of Rule based governance?
Make the answer very short. 0.58. In the year 2006, what is the difference between the Rating (1=low 6=high) of Macroeconomic management and Rating (1=low 6=high) of Rule based governance?
Make the answer very short. 0.97. In the year 2007, what is the difference between the Rating (1=low 6=high) of Revenue mobilization and Rating (1=low 6=high) of Public resource use?
Your answer should be very brief. 0.04. In the year 2007, what is the difference between the Rating (1=low 6=high) of Revenue mobilization and Rating (1=low 6=high) of Macroeconomic management?
Give a very brief answer. -0.36. In the year 2007, what is the difference between the Rating (1=low 6=high) in Revenue mobilization and Rating (1=low 6=high) in Rule based governance?
Make the answer very short. 0.59. In the year 2007, what is the difference between the Rating (1=low 6=high) of Public resource use and Rating (1=low 6=high) of Macroeconomic management?
Ensure brevity in your answer.  -0.39. In the year 2007, what is the difference between the Rating (1=low 6=high) of Public resource use and Rating (1=low 6=high) of Rule based governance?
Ensure brevity in your answer.  0.55. In the year 2007, what is the difference between the Rating (1=low 6=high) in Macroeconomic management and Rating (1=low 6=high) in Rule based governance?
Your response must be concise. 0.95. In the year 2008, what is the difference between the Rating (1=low 6=high) in Revenue mobilization and Rating (1=low 6=high) in Public resource use?
Your answer should be compact. 0.07. In the year 2008, what is the difference between the Rating (1=low 6=high) in Revenue mobilization and Rating (1=low 6=high) in Macroeconomic management?
Keep it short and to the point. -0.25. In the year 2008, what is the difference between the Rating (1=low 6=high) of Revenue mobilization and Rating (1=low 6=high) of Rule based governance?
Your answer should be compact. 0.61. In the year 2008, what is the difference between the Rating (1=low 6=high) in Public resource use and Rating (1=low 6=high) in Macroeconomic management?
Offer a terse response. -0.32. In the year 2008, what is the difference between the Rating (1=low 6=high) in Public resource use and Rating (1=low 6=high) in Rule based governance?
Offer a very short reply. 0.54. In the year 2008, what is the difference between the Rating (1=low 6=high) in Macroeconomic management and Rating (1=low 6=high) in Rule based governance?
Provide a short and direct response. 0.86. In the year 2009, what is the difference between the Rating (1=low 6=high) in Revenue mobilization and Rating (1=low 6=high) in Public resource use?
Provide a short and direct response. 0.03. In the year 2009, what is the difference between the Rating (1=low 6=high) of Revenue mobilization and Rating (1=low 6=high) of Macroeconomic management?
Your response must be concise. -0.24. In the year 2009, what is the difference between the Rating (1=low 6=high) of Revenue mobilization and Rating (1=low 6=high) of Rule based governance?
Your answer should be very brief. 0.6. In the year 2009, what is the difference between the Rating (1=low 6=high) of Public resource use and Rating (1=low 6=high) of Macroeconomic management?
Your response must be concise. -0.27. In the year 2009, what is the difference between the Rating (1=low 6=high) of Public resource use and Rating (1=low 6=high) of Rule based governance?
Keep it short and to the point. 0.58. In the year 2009, what is the difference between the Rating (1=low 6=high) in Macroeconomic management and Rating (1=low 6=high) in Rule based governance?
Your answer should be very brief. 0.85. In the year 2010, what is the difference between the Rating (1=low 6=high) of Revenue mobilization and Rating (1=low 6=high) of Public resource use?
Make the answer very short. -0.04. In the year 2010, what is the difference between the Rating (1=low 6=high) of Revenue mobilization and Rating (1=low 6=high) of Macroeconomic management?
Your answer should be very brief. -0.23. In the year 2010, what is the difference between the Rating (1=low 6=high) in Revenue mobilization and Rating (1=low 6=high) in Rule based governance?
Offer a terse response. 0.6. In the year 2010, what is the difference between the Rating (1=low 6=high) in Public resource use and Rating (1=low 6=high) in Macroeconomic management?
Give a very brief answer. -0.19. In the year 2010, what is the difference between the Rating (1=low 6=high) of Public resource use and Rating (1=low 6=high) of Rule based governance?
Ensure brevity in your answer.  0.64. In the year 2010, what is the difference between the Rating (1=low 6=high) of Macroeconomic management and Rating (1=low 6=high) of Rule based governance?
Make the answer very short. 0.83. In the year 2011, what is the difference between the Rating (1=low 6=high) in Revenue mobilization and Rating (1=low 6=high) in Public resource use?
Provide a short and direct response. -0.04. In the year 2011, what is the difference between the Rating (1=low 6=high) of Revenue mobilization and Rating (1=low 6=high) of Macroeconomic management?
Your answer should be compact. -0.17. In the year 2011, what is the difference between the Rating (1=low 6=high) in Revenue mobilization and Rating (1=low 6=high) in Rule based governance?
Your response must be concise. 0.59. In the year 2011, what is the difference between the Rating (1=low 6=high) in Public resource use and Rating (1=low 6=high) in Macroeconomic management?
Offer a terse response. -0.14. In the year 2011, what is the difference between the Rating (1=low 6=high) of Macroeconomic management and Rating (1=low 6=high) of Rule based governance?
Your answer should be compact. 0.76. In the year 2012, what is the difference between the Rating (1=low 6=high) in Revenue mobilization and Rating (1=low 6=high) in Public resource use?
Your response must be concise. -0.04. In the year 2012, what is the difference between the Rating (1=low 6=high) in Revenue mobilization and Rating (1=low 6=high) in Macroeconomic management?
Your answer should be compact. -0.19. In the year 2012, what is the difference between the Rating (1=low 6=high) of Public resource use and Rating (1=low 6=high) of Macroeconomic management?
Your response must be concise. -0.15. In the year 2012, what is the difference between the Rating (1=low 6=high) of Public resource use and Rating (1=low 6=high) of Rule based governance?
Your response must be concise. 0.64. In the year 2012, what is the difference between the Rating (1=low 6=high) of Macroeconomic management and Rating (1=low 6=high) of Rule based governance?
Provide a succinct answer. 0.79. In the year 2013, what is the difference between the Rating (1=low 6=high) in Revenue mobilization and Rating (1=low 6=high) in Public resource use?
Keep it short and to the point. 0. In the year 2013, what is the difference between the Rating (1=low 6=high) in Revenue mobilization and Rating (1=low 6=high) in Macroeconomic management?
Keep it short and to the point. -0.17. In the year 2013, what is the difference between the Rating (1=low 6=high) of Revenue mobilization and Rating (1=low 6=high) of Rule based governance?
Give a very brief answer. 0.6. In the year 2013, what is the difference between the Rating (1=low 6=high) in Public resource use and Rating (1=low 6=high) in Macroeconomic management?
Offer a terse response. -0.17. In the year 2013, what is the difference between the Rating (1=low 6=high) in Public resource use and Rating (1=low 6=high) in Rule based governance?
Make the answer very short. 0.6. In the year 2013, what is the difference between the Rating (1=low 6=high) in Macroeconomic management and Rating (1=low 6=high) in Rule based governance?
Provide a succinct answer. 0.77. What is the ratio of the Rating (1=low 6=high) of Revenue mobilization in 2005 to that in 2006?
Provide a succinct answer. 1. What is the ratio of the Rating (1=low 6=high) of Rule based governance in 2005 to that in 2006?
Provide a succinct answer. 1.02. What is the ratio of the Rating (1=low 6=high) in Revenue mobilization in 2005 to that in 2007?
Your answer should be very brief. 1.01. What is the ratio of the Rating (1=low 6=high) in Public resource use in 2005 to that in 2007?
Your response must be concise. 1. What is the ratio of the Rating (1=low 6=high) of Rule based governance in 2005 to that in 2007?
Your response must be concise. 1.01. What is the ratio of the Rating (1=low 6=high) in Macroeconomic management in 2005 to that in 2008?
Your response must be concise. 1.02. What is the ratio of the Rating (1=low 6=high) in Rule based governance in 2005 to that in 2008?
Offer a very short reply. 1.01. What is the ratio of the Rating (1=low 6=high) of Revenue mobilization in 2005 to that in 2009?
Provide a succinct answer. 1. What is the ratio of the Rating (1=low 6=high) of Public resource use in 2005 to that in 2009?
Provide a short and direct response. 0.99. What is the ratio of the Rating (1=low 6=high) of Macroeconomic management in 2005 to that in 2009?
Offer a terse response. 1.02. What is the ratio of the Rating (1=low 6=high) in Revenue mobilization in 2005 to that in 2010?
Your answer should be compact. 1. What is the ratio of the Rating (1=low 6=high) in Public resource use in 2005 to that in 2010?
Your response must be concise. 0.97. What is the ratio of the Rating (1=low 6=high) in Macroeconomic management in 2005 to that in 2010?
Keep it short and to the point. 1.02. What is the ratio of the Rating (1=low 6=high) of Public resource use in 2005 to that in 2011?
Give a very brief answer. 0.97. What is the ratio of the Rating (1=low 6=high) in Macroeconomic management in 2005 to that in 2011?
Ensure brevity in your answer.  1.04. What is the ratio of the Rating (1=low 6=high) in Rule based governance in 2005 to that in 2011?
Keep it short and to the point. 1. What is the ratio of the Rating (1=low 6=high) of Revenue mobilization in 2005 to that in 2012?
Provide a short and direct response. 0.99. What is the ratio of the Rating (1=low 6=high) of Public resource use in 2005 to that in 2012?
Your response must be concise. 0.97. What is the ratio of the Rating (1=low 6=high) of Macroeconomic management in 2005 to that in 2012?
Your response must be concise. 1.03. What is the ratio of the Rating (1=low 6=high) in Public resource use in 2005 to that in 2013?
Offer a terse response. 0.98. What is the ratio of the Rating (1=low 6=high) in Macroeconomic management in 2005 to that in 2013?
Your response must be concise. 1.04. What is the ratio of the Rating (1=low 6=high) in Rule based governance in 2005 to that in 2013?
Make the answer very short. 1. What is the ratio of the Rating (1=low 6=high) in Revenue mobilization in 2006 to that in 2007?
Your answer should be very brief. 1.01. What is the ratio of the Rating (1=low 6=high) in Public resource use in 2006 to that in 2007?
Ensure brevity in your answer.  1. What is the ratio of the Rating (1=low 6=high) in Rule based governance in 2006 to that in 2007?
Keep it short and to the point. 1. What is the ratio of the Rating (1=low 6=high) in Revenue mobilization in 2006 to that in 2008?
Provide a succinct answer. 1. What is the ratio of the Rating (1=low 6=high) in Macroeconomic management in 2006 to that in 2008?
Offer a very short reply. 1.03. What is the ratio of the Rating (1=low 6=high) in Public resource use in 2006 to that in 2009?
Provide a short and direct response. 0.99. What is the ratio of the Rating (1=low 6=high) of Macroeconomic management in 2006 to that in 2009?
Make the answer very short. 1.02. What is the ratio of the Rating (1=low 6=high) of Public resource use in 2006 to that in 2010?
Ensure brevity in your answer.  0.97. What is the ratio of the Rating (1=low 6=high) of Macroeconomic management in 2006 to that in 2010?
Make the answer very short. 1.03. What is the ratio of the Rating (1=low 6=high) in Macroeconomic management in 2006 to that in 2011?
Your answer should be compact. 1.04. What is the ratio of the Rating (1=low 6=high) of Rule based governance in 2006 to that in 2011?
Your answer should be very brief. 0.98. What is the ratio of the Rating (1=low 6=high) of Revenue mobilization in 2006 to that in 2012?
Offer a very short reply. 0.99. What is the ratio of the Rating (1=low 6=high) in Public resource use in 2006 to that in 2012?
Your response must be concise. 0.97. What is the ratio of the Rating (1=low 6=high) in Macroeconomic management in 2006 to that in 2012?
Your response must be concise. 1.03. What is the ratio of the Rating (1=low 6=high) of Rule based governance in 2006 to that in 2012?
Keep it short and to the point. 0.98. What is the ratio of the Rating (1=low 6=high) of Public resource use in 2006 to that in 2013?
Offer a very short reply. 0.98. What is the ratio of the Rating (1=low 6=high) of Macroeconomic management in 2006 to that in 2013?
Give a very brief answer. 1.04. What is the ratio of the Rating (1=low 6=high) of Rule based governance in 2006 to that in 2013?
Provide a short and direct response. 0.98. What is the ratio of the Rating (1=low 6=high) in Public resource use in 2007 to that in 2008?
Offer a very short reply. 1. What is the ratio of the Rating (1=low 6=high) in Macroeconomic management in 2007 to that in 2008?
Keep it short and to the point. 1.02. What is the ratio of the Rating (1=low 6=high) in Rule based governance in 2007 to that in 2008?
Offer a terse response. 1. What is the ratio of the Rating (1=low 6=high) in Revenue mobilization in 2007 to that in 2009?
Provide a short and direct response. 0.99. What is the ratio of the Rating (1=low 6=high) of Public resource use in 2007 to that in 2009?
Your answer should be compact. 0.99. What is the ratio of the Rating (1=low 6=high) in Macroeconomic management in 2007 to that in 2009?
Your answer should be compact. 1.02. What is the ratio of the Rating (1=low 6=high) of Rule based governance in 2007 to that in 2009?
Make the answer very short. 0.99. What is the ratio of the Rating (1=low 6=high) of Revenue mobilization in 2007 to that in 2010?
Keep it short and to the point. 0.99. What is the ratio of the Rating (1=low 6=high) of Macroeconomic management in 2007 to that in 2010?
Your response must be concise. 1.02. What is the ratio of the Rating (1=low 6=high) of Rule based governance in 2007 to that in 2010?
Ensure brevity in your answer.  0.99. What is the ratio of the Rating (1=low 6=high) of Public resource use in 2007 to that in 2011?
Your answer should be very brief. 0.97. What is the ratio of the Rating (1=low 6=high) in Macroeconomic management in 2007 to that in 2011?
Make the answer very short. 1.04. What is the ratio of the Rating (1=low 6=high) in Rule based governance in 2007 to that in 2011?
Give a very brief answer. 0.99. What is the ratio of the Rating (1=low 6=high) of Revenue mobilization in 2007 to that in 2012?
Provide a short and direct response. 0.98. What is the ratio of the Rating (1=low 6=high) in Public resource use in 2007 to that in 2012?
Your answer should be compact. 0.96. What is the ratio of the Rating (1=low 6=high) in Macroeconomic management in 2007 to that in 2012?
Offer a terse response. 1.03. What is the ratio of the Rating (1=low 6=high) in Rule based governance in 2007 to that in 2012?
Offer a very short reply. 0.98. What is the ratio of the Rating (1=low 6=high) of Revenue mobilization in 2007 to that in 2013?
Offer a very short reply. 0.99. What is the ratio of the Rating (1=low 6=high) of Public resource use in 2007 to that in 2013?
Ensure brevity in your answer.  0.98. What is the ratio of the Rating (1=low 6=high) in Macroeconomic management in 2007 to that in 2013?
Ensure brevity in your answer.  1.04. What is the ratio of the Rating (1=low 6=high) in Rule based governance in 2007 to that in 2013?
Provide a short and direct response. 0.99. What is the ratio of the Rating (1=low 6=high) in Public resource use in 2008 to that in 2009?
Provide a short and direct response. 0.99. What is the ratio of the Rating (1=low 6=high) of Revenue mobilization in 2008 to that in 2010?
Your answer should be compact. 1. What is the ratio of the Rating (1=low 6=high) in Public resource use in 2008 to that in 2010?
Make the answer very short. 0.97. What is the ratio of the Rating (1=low 6=high) in Macroeconomic management in 2008 to that in 2010?
Give a very brief answer. 1. What is the ratio of the Rating (1=low 6=high) of Revenue mobilization in 2008 to that in 2011?
Provide a short and direct response. 1. What is the ratio of the Rating (1=low 6=high) of Public resource use in 2008 to that in 2011?
Offer a terse response. 0.97. What is the ratio of the Rating (1=low 6=high) in Macroeconomic management in 2008 to that in 2011?
Ensure brevity in your answer.  1.02. What is the ratio of the Rating (1=low 6=high) of Rule based governance in 2008 to that in 2011?
Provide a short and direct response. 0.99. What is the ratio of the Rating (1=low 6=high) of Public resource use in 2008 to that in 2012?
Provide a short and direct response. 0.96. What is the ratio of the Rating (1=low 6=high) of Rule based governance in 2008 to that in 2012?
Provide a succinct answer. 0.99. What is the ratio of the Rating (1=low 6=high) in Public resource use in 2008 to that in 2013?
Make the answer very short. 0.98. What is the ratio of the Rating (1=low 6=high) of Macroeconomic management in 2008 to that in 2013?
Give a very brief answer. 1.02. What is the ratio of the Rating (1=low 6=high) of Rule based governance in 2008 to that in 2013?
Your answer should be compact. 0.99. What is the ratio of the Rating (1=low 6=high) of Revenue mobilization in 2009 to that in 2010?
Your answer should be very brief. 1. What is the ratio of the Rating (1=low 6=high) in Public resource use in 2009 to that in 2010?
Your answer should be very brief. 0.98. What is the ratio of the Rating (1=low 6=high) in Revenue mobilization in 2009 to that in 2011?
Your answer should be compact. 1. What is the ratio of the Rating (1=low 6=high) of Public resource use in 2009 to that in 2011?
Your answer should be compact. 0.98. What is the ratio of the Rating (1=low 6=high) of Macroeconomic management in 2009 to that in 2011?
Ensure brevity in your answer.  1.02. What is the ratio of the Rating (1=low 6=high) of Rule based governance in 2009 to that in 2011?
Keep it short and to the point. 1. What is the ratio of the Rating (1=low 6=high) of Public resource use in 2009 to that in 2012?
Ensure brevity in your answer.  0.98. What is the ratio of the Rating (1=low 6=high) of Macroeconomic management in 2009 to that in 2012?
Make the answer very short. 1.01. What is the ratio of the Rating (1=low 6=high) of Revenue mobilization in 2009 to that in 2013?
Your response must be concise. 1. What is the ratio of the Rating (1=low 6=high) of Public resource use in 2009 to that in 2013?
Offer a terse response. 0.99. What is the ratio of the Rating (1=low 6=high) of Macroeconomic management in 2009 to that in 2013?
Keep it short and to the point. 1.02. What is the ratio of the Rating (1=low 6=high) of Rule based governance in 2009 to that in 2013?
Provide a succinct answer. 0.99. What is the ratio of the Rating (1=low 6=high) in Public resource use in 2010 to that in 2011?
Provide a succinct answer. 1. What is the ratio of the Rating (1=low 6=high) of Macroeconomic management in 2010 to that in 2011?
Give a very brief answer. 1.02. What is the ratio of the Rating (1=low 6=high) in Revenue mobilization in 2010 to that in 2012?
Provide a short and direct response. 0.99. What is the ratio of the Rating (1=low 6=high) of Revenue mobilization in 2010 to that in 2013?
Your answer should be compact. 1. What is the ratio of the Rating (1=low 6=high) in Macroeconomic management in 2010 to that in 2013?
Give a very brief answer. 1.01. What is the ratio of the Rating (1=low 6=high) of Revenue mobilization in 2011 to that in 2012?
Ensure brevity in your answer.  0.99. What is the ratio of the Rating (1=low 6=high) of Public resource use in 2011 to that in 2012?
Your answer should be compact. 0.99. What is the ratio of the Rating (1=low 6=high) in Macroeconomic management in 2011 to that in 2012?
Ensure brevity in your answer.  0.99. What is the ratio of the Rating (1=low 6=high) of Rule based governance in 2011 to that in 2012?
Provide a short and direct response. 1. What is the ratio of the Rating (1=low 6=high) of Public resource use in 2011 to that in 2013?
Provide a short and direct response. 1.01. What is the ratio of the Rating (1=low 6=high) in Rule based governance in 2011 to that in 2013?
Your answer should be very brief. 1. What is the ratio of the Rating (1=low 6=high) in Revenue mobilization in 2012 to that in 2013?
Offer a very short reply. 1. What is the ratio of the Rating (1=low 6=high) of Public resource use in 2012 to that in 2013?
Your response must be concise. 1.01. What is the ratio of the Rating (1=low 6=high) in Macroeconomic management in 2012 to that in 2013?
Your answer should be compact. 1.01. What is the difference between the highest and the second highest Rating (1=low 6=high) of Revenue mobilization?
Provide a succinct answer. 0.01. What is the difference between the highest and the second highest Rating (1=low 6=high) in Public resource use?
Provide a short and direct response. 0.02. What is the difference between the highest and the second highest Rating (1=low 6=high) in Macroeconomic management?
Your response must be concise. 0.02. What is the difference between the highest and the second highest Rating (1=low 6=high) in Rule based governance?
Offer a terse response. 0.01. What is the difference between the highest and the lowest Rating (1=low 6=high) of Revenue mobilization?
Make the answer very short. 0.06. What is the difference between the highest and the lowest Rating (1=low 6=high) in Public resource use?
Give a very brief answer. 0.14. What is the difference between the highest and the lowest Rating (1=low 6=high) of Macroeconomic management?
Your response must be concise. 0.16. What is the difference between the highest and the lowest Rating (1=low 6=high) of Rule based governance?
Provide a succinct answer. 0.06. 